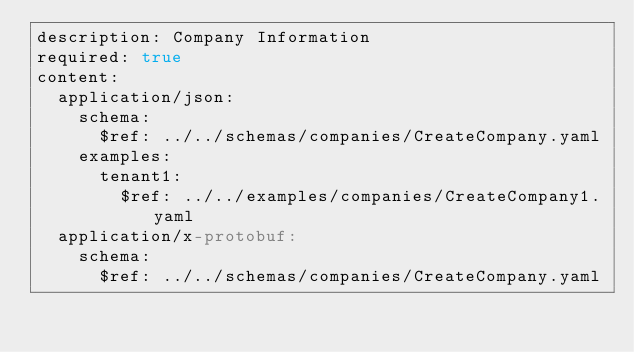Convert code to text. <code><loc_0><loc_0><loc_500><loc_500><_YAML_>description: Company Information
required: true
content:
  application/json:
    schema:
      $ref: ../../schemas/companies/CreateCompany.yaml
    examples:
      tenant1:
        $ref: ../../examples/companies/CreateCompany1.yaml
  application/x-protobuf:
    schema:
      $ref: ../../schemas/companies/CreateCompany.yaml
</code> 